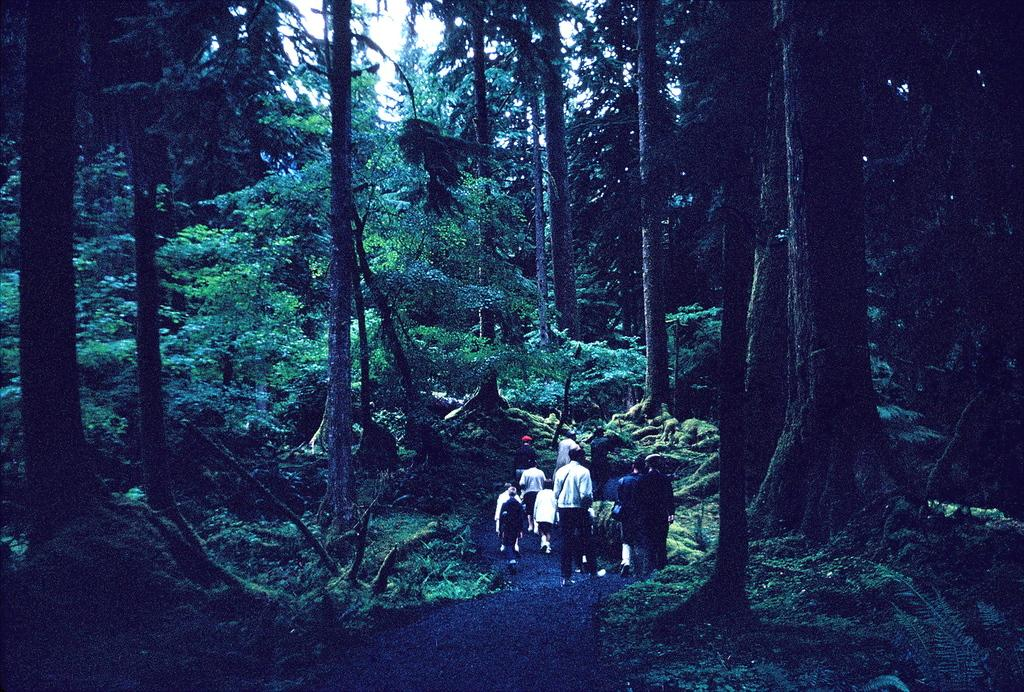How many people are in the group visible in the image? The number of people in the group cannot be determined from the provided facts. What type of vegetation is present in the image? There are trees and grass in the image. What is visible in the background of the image? The sky is visible in the image. What is the lighting condition in the image? The image appears to be slightly dark. How does the company increase its profits in the image? There is no mention of a company or any financial information in the image. What objects are being smashed in the image? There is no indication of any objects being smashed in the image. 